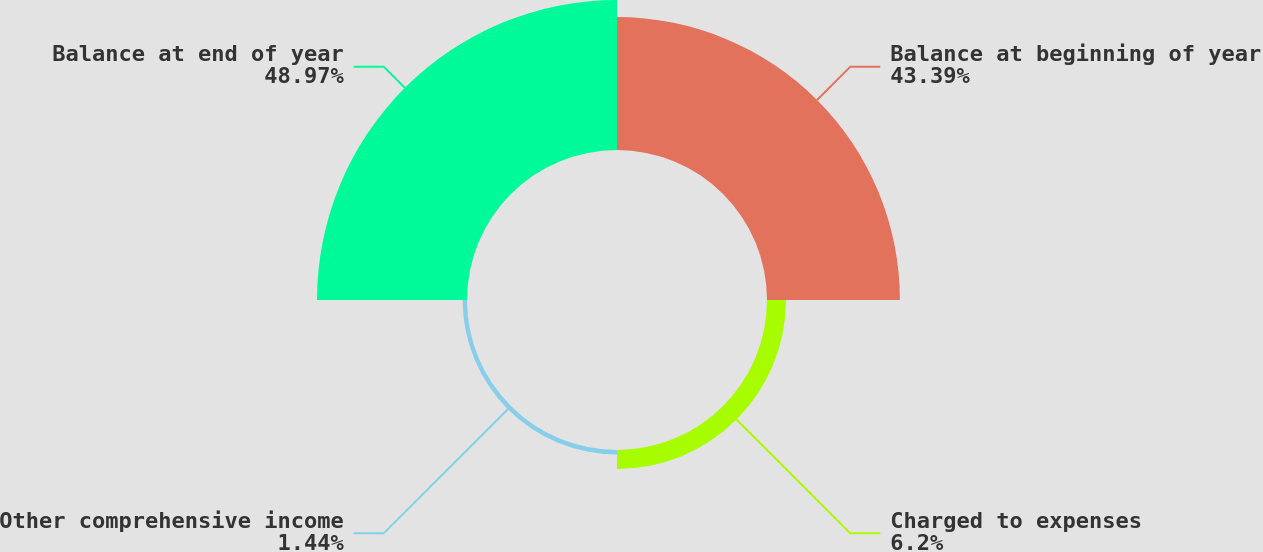<chart> <loc_0><loc_0><loc_500><loc_500><pie_chart><fcel>Balance at beginning of year<fcel>Charged to expenses<fcel>Other comprehensive income<fcel>Balance at end of year<nl><fcel>43.39%<fcel>6.2%<fcel>1.44%<fcel>48.97%<nl></chart> 